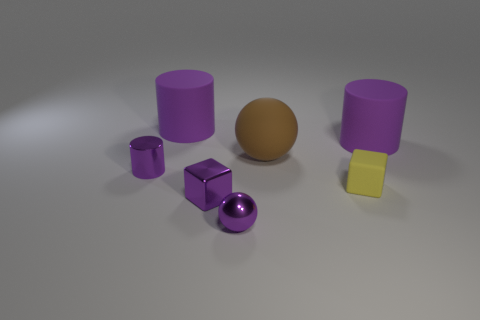Add 1 green matte things. How many objects exist? 8 Subtract all blocks. How many objects are left? 5 Add 1 small cubes. How many small cubes exist? 3 Subtract 0 yellow spheres. How many objects are left? 7 Subtract all gray shiny spheres. Subtract all tiny purple spheres. How many objects are left? 6 Add 4 purple cylinders. How many purple cylinders are left? 7 